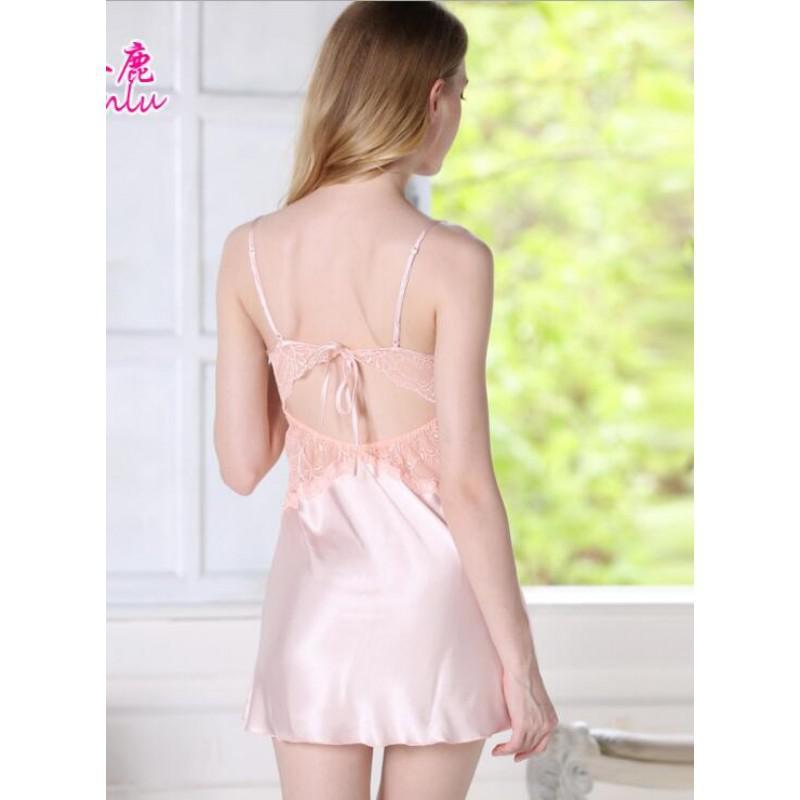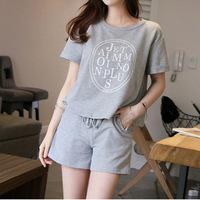The first image is the image on the left, the second image is the image on the right. For the images displayed, is the sentence "One model is blonde and wears something made of satiny, shiny material, while the other model wears shorts with a short-sleeved top that doesn't bare her midriff." factually correct? Answer yes or no. Yes. The first image is the image on the left, the second image is the image on the right. Assess this claim about the two images: "A pajama set is a pair of short pants paired with a t-shirt top with short sleeves and design printed on the front.". Correct or not? Answer yes or no. Yes. 